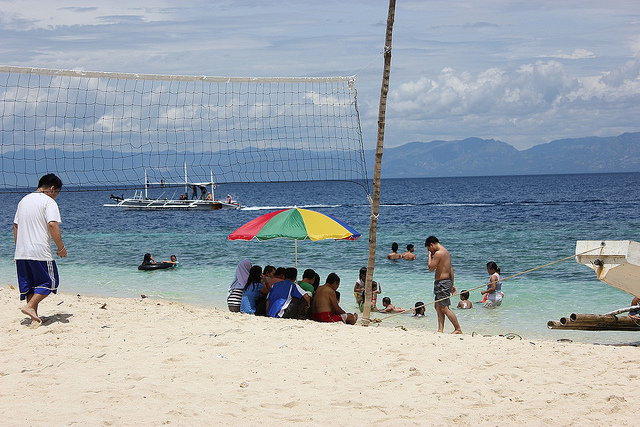<image>What game is being played? I don't know what game is being played. It could be volleyball or charades. What game is being played? It is ambiguous what game is being played. It can be either volleyball or charades. 